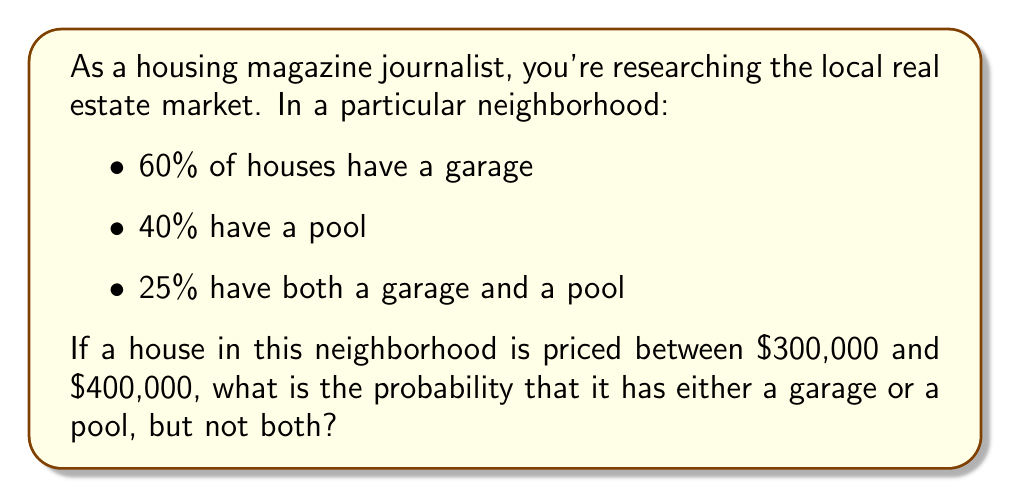Can you solve this math problem? To solve this problem, we'll use the concept of set theory and probability.

Let's define our events:
$G$: The house has a garage
$P$: The house has a pool

We're given:
$P(G) = 0.60$
$P(P) = 0.40$
$P(G \cap P) = 0.25$

We want to find $P(G \triangle P)$, where $\triangle$ represents the symmetric difference (either $G$ or $P$, but not both).

Step 1: Use the formula for the probability of a union:
$$P(G \cup P) = P(G) + P(P) - P(G \cap P)$$
$$P(G \cup P) = 0.60 + 0.40 - 0.25 = 0.75$$

Step 2: The probability of either $G$ or $P$ (but not both) is the difference between the probability of their union and the probability of their intersection:
$$P(G \triangle P) = P(G \cup P) - P(G \cap P)$$
$$P(G \triangle P) = 0.75 - 0.25 = 0.50$$

Therefore, the probability of a house in this price range having either a garage or a pool, but not both, is 0.50 or 50%.
Answer: The probability is 0.50 or 50%. 